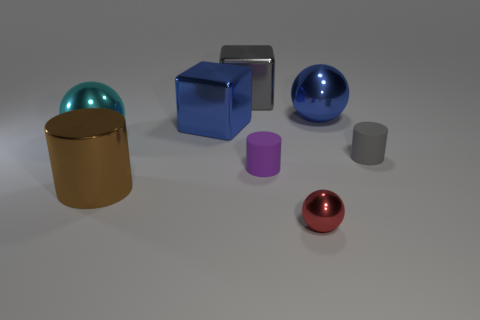What color is the metallic sphere in front of the matte cylinder on the left side of the rubber object behind the small purple rubber cylinder?
Give a very brief answer. Red. Is the blue cube made of the same material as the sphere behind the cyan sphere?
Make the answer very short. Yes. What is the material of the tiny red thing?
Give a very brief answer. Metal. How many other objects are there of the same material as the tiny gray object?
Give a very brief answer. 1. What shape is the object that is in front of the tiny purple rubber object and on the left side of the large gray metallic block?
Provide a succinct answer. Cylinder. There is a cylinder that is the same material as the large gray block; what color is it?
Provide a succinct answer. Brown. Are there an equal number of tiny shiny balls that are right of the tiny red ball and brown metal balls?
Your answer should be very brief. Yes. What is the shape of the metal thing that is the same size as the gray rubber object?
Give a very brief answer. Sphere. How many other things are there of the same shape as the gray metallic thing?
Keep it short and to the point. 1. There is a cyan shiny thing; is it the same size as the shiny cube that is in front of the big gray metal thing?
Offer a terse response. Yes. 